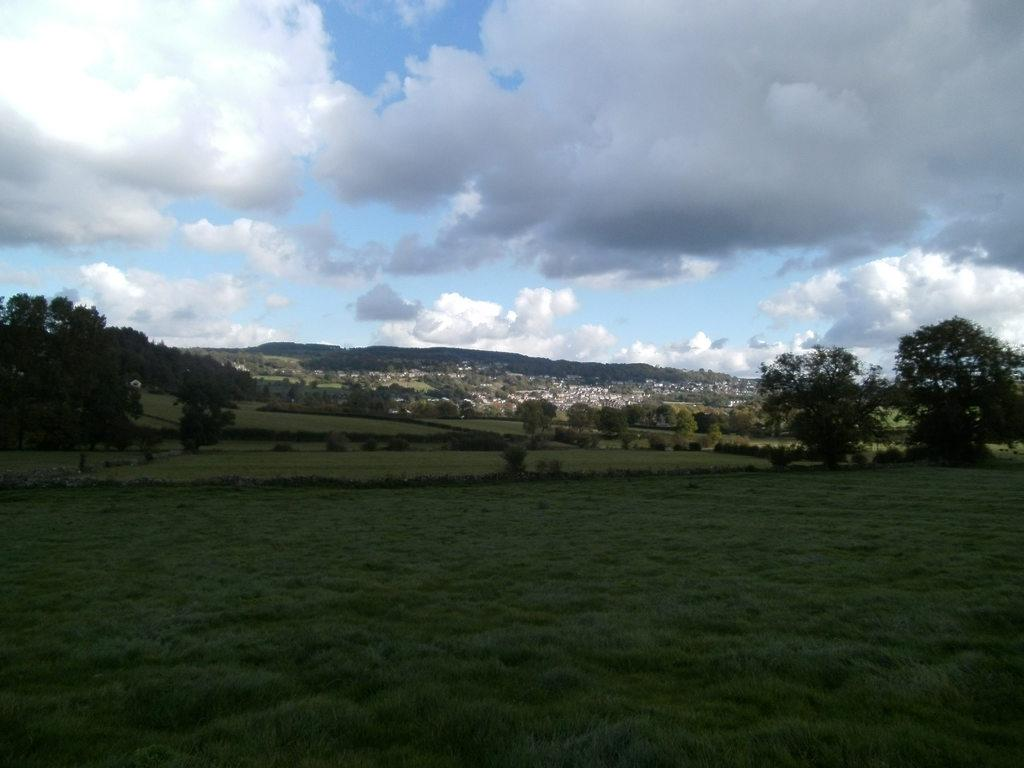What type of terrain is visible at the bottom of the image? There is grass on the ground at the bottom of the image. What can be seen in the background of the image? There are trees, buildings, and hills in the background of the image. What is visible at the top of the image? The sky is visible at the top of the image. What can be observed in the sky? There are clouds in the sky. Can you tell me how many dogs are playing in the amusement park in the image? There is no amusement park or dogs present in the image. 